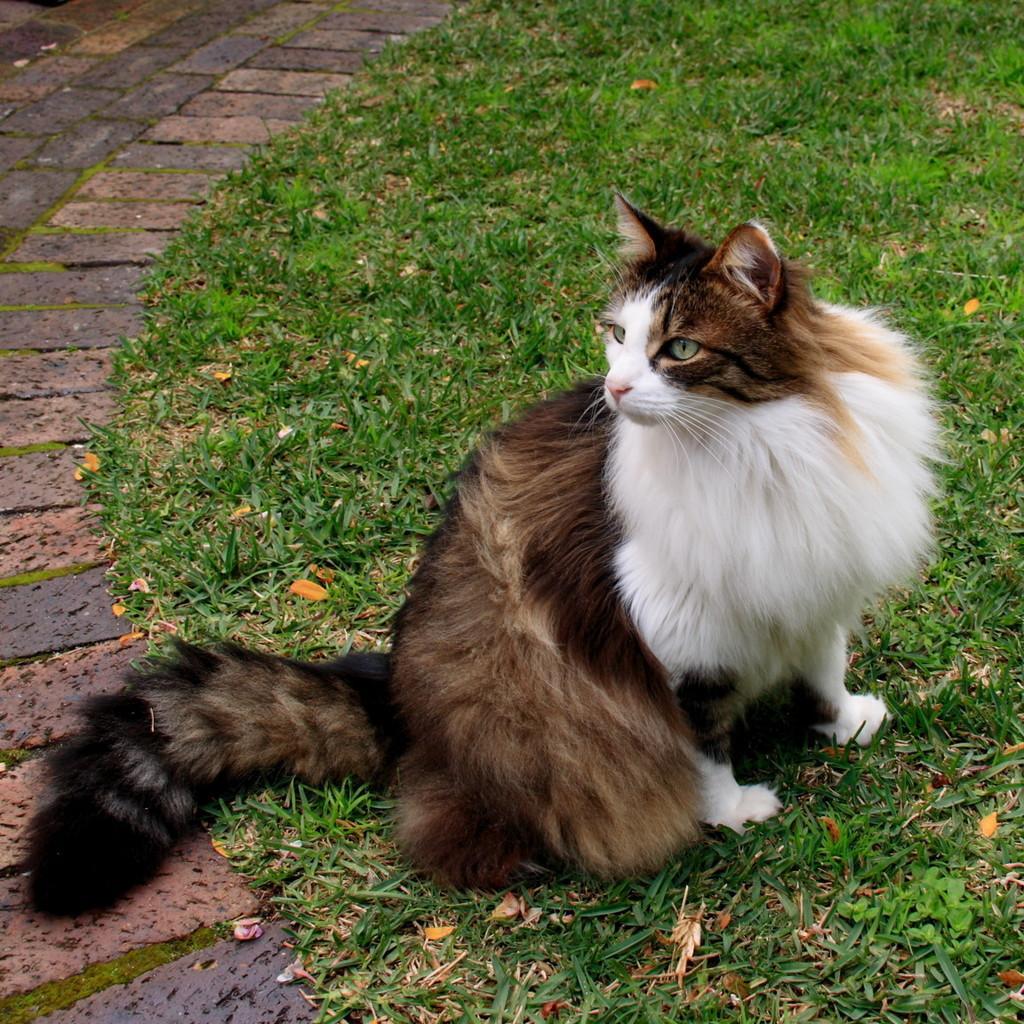Please provide a concise description of this image. In this image there is a cat sat on the surface of the grass. On the left side of the image there is a path. 